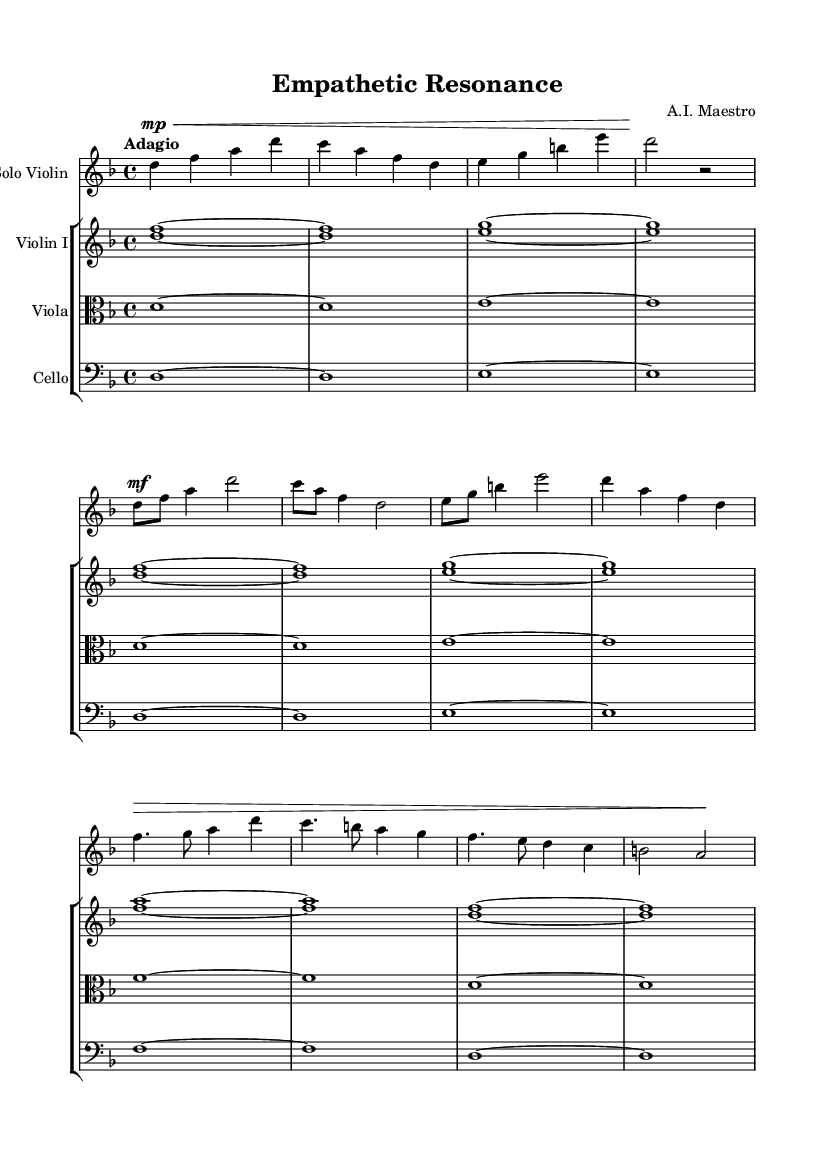What is the key signature of this music? The key signature is D minor, which contains one flat (B) indicating that B is lowered in pitch.
Answer: D minor What is the time signature of this music? The time signature is 4/4, which means there are four beats in each measure and the quarter note gets one beat.
Answer: 4/4 What is the tempo marking for this piece? The tempo is marked as "Adagio," which indicates a slow and relaxed pace for the music.
Answer: Adagio How many themes are presented in the piece? There are two distinct themes presented in the music: Theme A and Theme B.
Answer: Two Which section features a crescendo? The section labeled "Theme B" features a crescendo, as indicated by the dynamic marking that suggests a gradual increase in volume.
Answer: Theme B What is the dynamic marking for the introduction? The dynamic marking for the introduction is "mp" (mezzo-piano), indicating a moderately soft volume.
Answer: mp What instrument plays the solo part? The solo part is played by the violin, as indicated by the instrument name specified in the staff.
Answer: Violin 